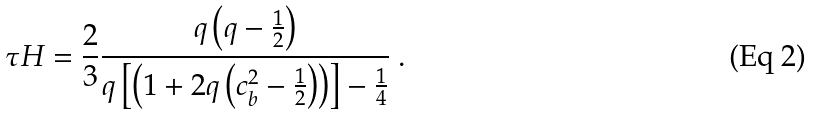<formula> <loc_0><loc_0><loc_500><loc_500>\tau H = \frac { 2 } { 3 } \frac { q \left ( q - \frac { 1 } { 2 } \right ) } { q \left [ \left ( 1 + 2 q \left ( c _ { b } ^ { 2 } - \frac { 1 } { 2 } \right ) \right ) \right ] - \frac { 1 } { 4 } } \ .</formula> 